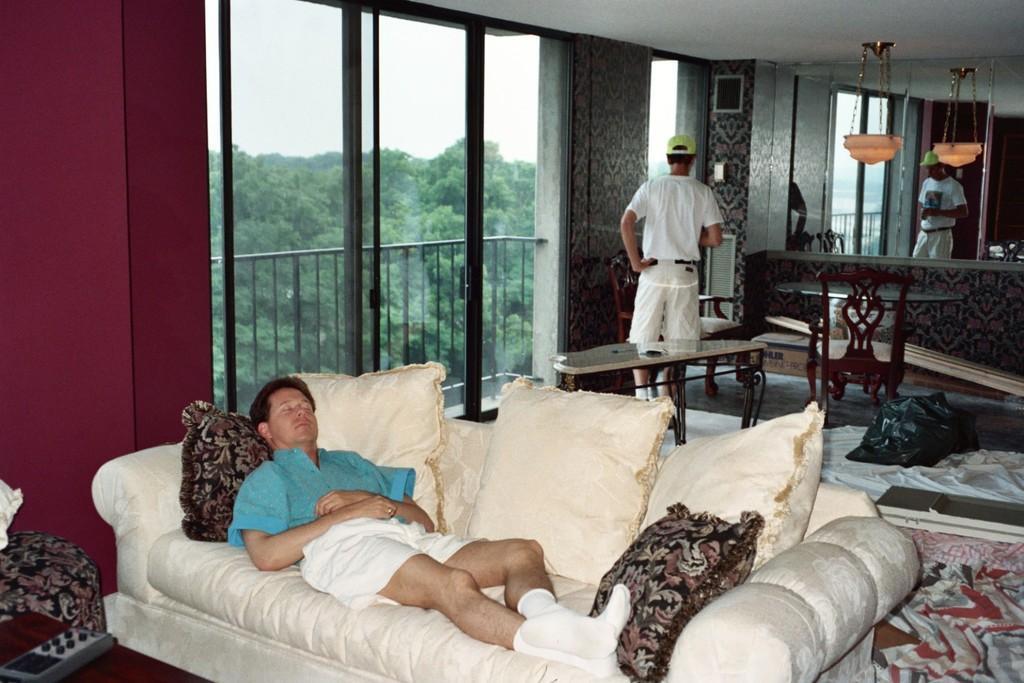Please provide a concise description of this image. In this image there are two persons at the foreground of the image there is a person sleeping on the couch and at the right side of the image there is a person standing on the floor and at the background of the image there are trees and fencing. 